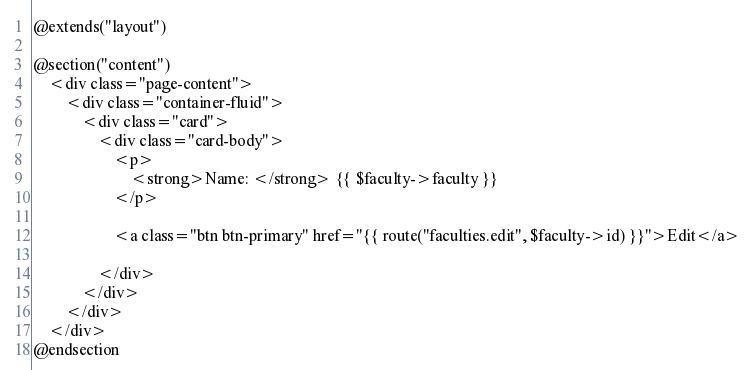<code> <loc_0><loc_0><loc_500><loc_500><_PHP_>@extends("layout")

@section("content")
    <div class="page-content">
        <div class="container-fluid">
            <div class="card">
                <div class="card-body">
                    <p>
                        <strong>Name: </strong> {{ $faculty->faculty }}
                    </p>
                    
                    <a class="btn btn-primary" href="{{ route("faculties.edit", $faculty->id) }}">Edit</a>

                </div>
            </div>
        </div>
    </div>
@endsection
</code> 